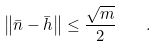<formula> <loc_0><loc_0><loc_500><loc_500>\left \| \bar { n } - \bar { h } \right \| \leq \frac { \sqrt { m } } { 2 } \quad .</formula> 